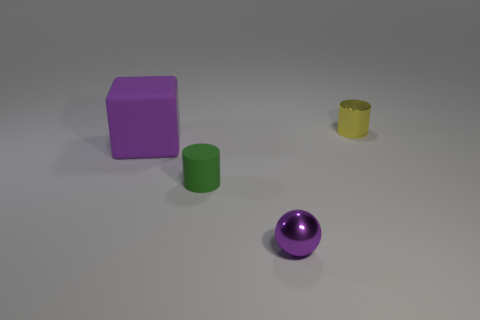What shapes and colors can you identify in the image? In the image, I can identify several shapes and their corresponding colors. There is a large purple cube on the left, a green cylinder in the middle, a yellow cylindrical ring or hollow object slightly behind the green cylinder, and a purple sphere on the right side of the image. The background is a neutral light gray, which provides a contrast that makes the colored objects stand out. 